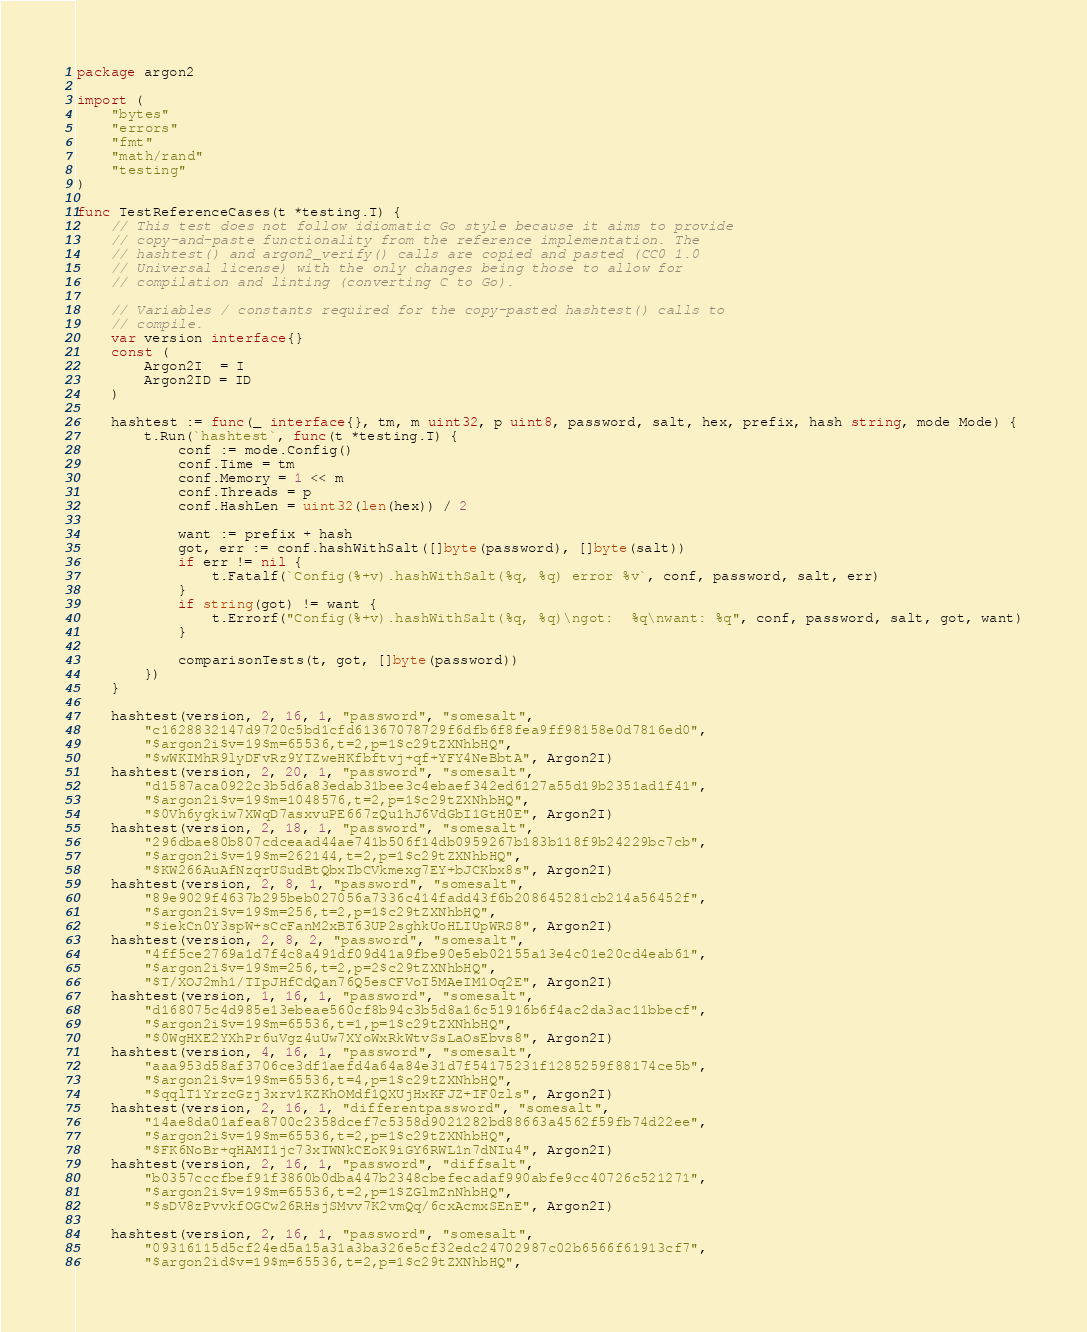<code> <loc_0><loc_0><loc_500><loc_500><_Go_>package argon2

import (
	"bytes"
	"errors"
	"fmt"
	"math/rand"
	"testing"
)

func TestReferenceCases(t *testing.T) {
	// This test does not follow idiomatic Go style because it aims to provide
	// copy-and-paste functionality from the reference implementation. The
	// hashtest() and argon2_verify() calls are copied and pasted (CC0 1.0
	// Universal license) with the only changes being those to allow for
	// compilation and linting (converting C to Go).

	// Variables / constants required for the copy-pasted hashtest() calls to
	// compile.
	var version interface{}
	const (
		Argon2I  = I
		Argon2ID = ID
	)

	hashtest := func(_ interface{}, tm, m uint32, p uint8, password, salt, hex, prefix, hash string, mode Mode) {
		t.Run(`hashtest`, func(t *testing.T) {
			conf := mode.Config()
			conf.Time = tm
			conf.Memory = 1 << m
			conf.Threads = p
			conf.HashLen = uint32(len(hex)) / 2

			want := prefix + hash
			got, err := conf.hashWithSalt([]byte(password), []byte(salt))
			if err != nil {
				t.Fatalf(`Config(%+v).hashWithSalt(%q, %q) error %v`, conf, password, salt, err)
			}
			if string(got) != want {
				t.Errorf("Config(%+v).hashWithSalt(%q, %q)\ngot:  %q\nwant: %q", conf, password, salt, got, want)
			}

			comparisonTests(t, got, []byte(password))
		})
	}

	hashtest(version, 2, 16, 1, "password", "somesalt",
		"c1628832147d9720c5bd1cfd61367078729f6dfb6f8fea9ff98158e0d7816ed0",
		"$argon2i$v=19$m=65536,t=2,p=1$c29tZXNhbHQ",
		"$wWKIMhR9lyDFvRz9YTZweHKfbftvj+qf+YFY4NeBbtA", Argon2I)
	hashtest(version, 2, 20, 1, "password", "somesalt",
		"d1587aca0922c3b5d6a83edab31bee3c4ebaef342ed6127a55d19b2351ad1f41",
		"$argon2i$v=19$m=1048576,t=2,p=1$c29tZXNhbHQ",
		"$0Vh6ygkiw7XWqD7asxvuPE667zQu1hJ6VdGbI1GtH0E", Argon2I)
	hashtest(version, 2, 18, 1, "password", "somesalt",
		"296dbae80b807cdceaad44ae741b506f14db0959267b183b118f9b24229bc7cb",
		"$argon2i$v=19$m=262144,t=2,p=1$c29tZXNhbHQ",
		"$KW266AuAfNzqrUSudBtQbxTbCVkmexg7EY+bJCKbx8s", Argon2I)
	hashtest(version, 2, 8, 1, "password", "somesalt",
		"89e9029f4637b295beb027056a7336c414fadd43f6b208645281cb214a56452f",
		"$argon2i$v=19$m=256,t=2,p=1$c29tZXNhbHQ",
		"$iekCn0Y3spW+sCcFanM2xBT63UP2sghkUoHLIUpWRS8", Argon2I)
	hashtest(version, 2, 8, 2, "password", "somesalt",
		"4ff5ce2769a1d7f4c8a491df09d41a9fbe90e5eb02155a13e4c01e20cd4eab61",
		"$argon2i$v=19$m=256,t=2,p=2$c29tZXNhbHQ",
		"$T/XOJ2mh1/TIpJHfCdQan76Q5esCFVoT5MAeIM1Oq2E", Argon2I)
	hashtest(version, 1, 16, 1, "password", "somesalt",
		"d168075c4d985e13ebeae560cf8b94c3b5d8a16c51916b6f4ac2da3ac11bbecf",
		"$argon2i$v=19$m=65536,t=1,p=1$c29tZXNhbHQ",
		"$0WgHXE2YXhPr6uVgz4uUw7XYoWxRkWtvSsLaOsEbvs8", Argon2I)
	hashtest(version, 4, 16, 1, "password", "somesalt",
		"aaa953d58af3706ce3df1aefd4a64a84e31d7f54175231f1285259f88174ce5b",
		"$argon2i$v=19$m=65536,t=4,p=1$c29tZXNhbHQ",
		"$qqlT1YrzcGzj3xrv1KZKhOMdf1QXUjHxKFJZ+IF0zls", Argon2I)
	hashtest(version, 2, 16, 1, "differentpassword", "somesalt",
		"14ae8da01afea8700c2358dcef7c5358d9021282bd88663a4562f59fb74d22ee",
		"$argon2i$v=19$m=65536,t=2,p=1$c29tZXNhbHQ",
		"$FK6NoBr+qHAMI1jc73xTWNkCEoK9iGY6RWL1n7dNIu4", Argon2I)
	hashtest(version, 2, 16, 1, "password", "diffsalt",
		"b0357cccfbef91f3860b0dba447b2348cbefecadaf990abfe9cc40726c521271",
		"$argon2i$v=19$m=65536,t=2,p=1$ZGlmZnNhbHQ",
		"$sDV8zPvvkfOGCw26RHsjSMvv7K2vmQq/6cxAcmxSEnE", Argon2I)

	hashtest(version, 2, 16, 1, "password", "somesalt",
		"09316115d5cf24ed5a15a31a3ba326e5cf32edc24702987c02b6566f61913cf7",
		"$argon2id$v=19$m=65536,t=2,p=1$c29tZXNhbHQ",</code> 